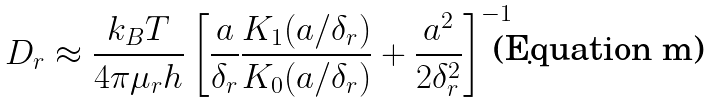Convert formula to latex. <formula><loc_0><loc_0><loc_500><loc_500>D _ { r } \approx \frac { k _ { B } T } { 4 \pi \mu _ { r } h } \left [ \frac { a } { \delta _ { r } } \frac { K _ { 1 } ( a / \delta _ { r } ) } { K _ { 0 } ( a / \delta _ { r } ) } + \frac { a ^ { 2 } } { 2 \delta _ { r } ^ { 2 } } \right ] ^ { - 1 } \, .</formula> 